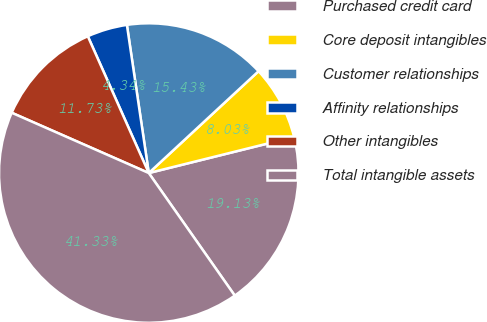Convert chart. <chart><loc_0><loc_0><loc_500><loc_500><pie_chart><fcel>Purchased credit card<fcel>Core deposit intangibles<fcel>Customer relationships<fcel>Affinity relationships<fcel>Other intangibles<fcel>Total intangible assets<nl><fcel>19.13%<fcel>8.03%<fcel>15.43%<fcel>4.34%<fcel>11.73%<fcel>41.33%<nl></chart> 